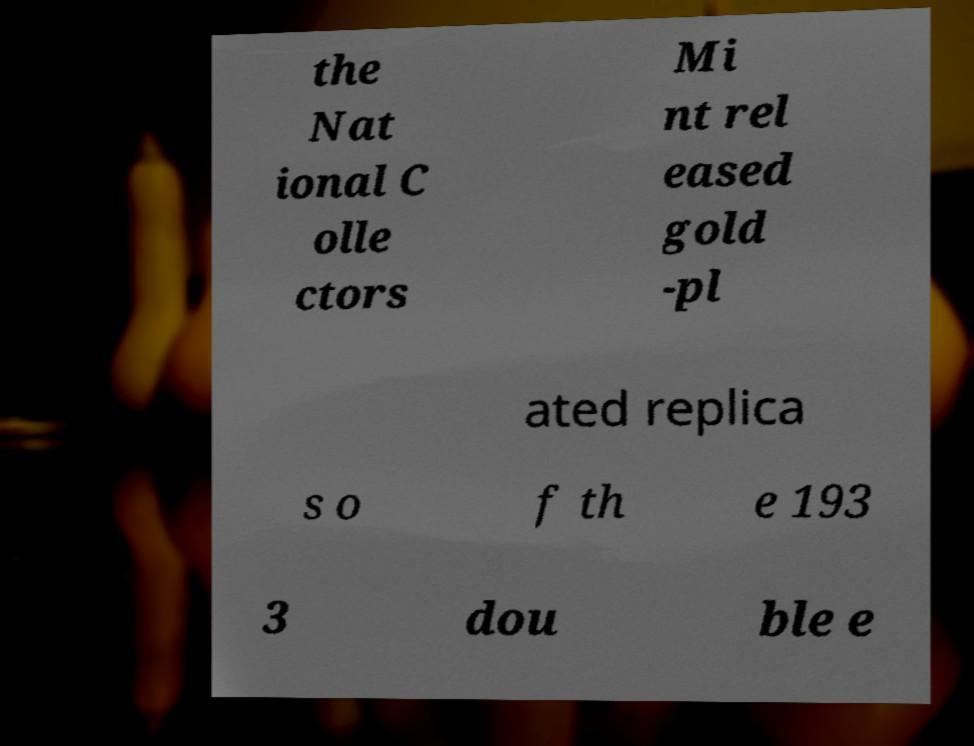There's text embedded in this image that I need extracted. Can you transcribe it verbatim? the Nat ional C olle ctors Mi nt rel eased gold -pl ated replica s o f th e 193 3 dou ble e 